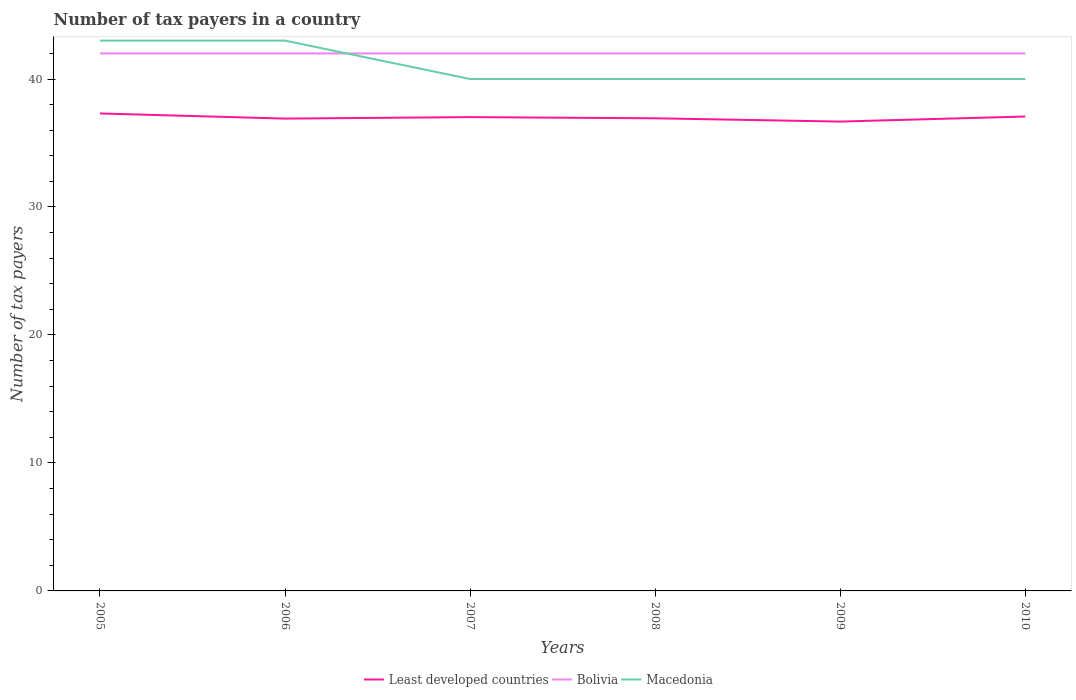How many different coloured lines are there?
Your answer should be very brief. 3. Is the number of lines equal to the number of legend labels?
Give a very brief answer. Yes. Across all years, what is the maximum number of tax payers in in Bolivia?
Your answer should be very brief. 42. What is the total number of tax payers in in Bolivia in the graph?
Your answer should be very brief. 0. What is the difference between the highest and the second highest number of tax payers in in Macedonia?
Give a very brief answer. 3. What is the difference between the highest and the lowest number of tax payers in in Macedonia?
Ensure brevity in your answer.  2. What is the difference between two consecutive major ticks on the Y-axis?
Give a very brief answer. 10. Are the values on the major ticks of Y-axis written in scientific E-notation?
Keep it short and to the point. No. Does the graph contain grids?
Your answer should be very brief. No. How many legend labels are there?
Your response must be concise. 3. How are the legend labels stacked?
Ensure brevity in your answer.  Horizontal. What is the title of the graph?
Keep it short and to the point. Number of tax payers in a country. Does "French Polynesia" appear as one of the legend labels in the graph?
Your answer should be compact. No. What is the label or title of the X-axis?
Ensure brevity in your answer.  Years. What is the label or title of the Y-axis?
Give a very brief answer. Number of tax payers. What is the Number of tax payers in Least developed countries in 2005?
Your answer should be very brief. 37.31. What is the Number of tax payers of Least developed countries in 2006?
Provide a succinct answer. 36.91. What is the Number of tax payers in Macedonia in 2006?
Offer a terse response. 43. What is the Number of tax payers in Least developed countries in 2007?
Ensure brevity in your answer.  37.02. What is the Number of tax payers of Bolivia in 2007?
Ensure brevity in your answer.  42. What is the Number of tax payers in Macedonia in 2007?
Keep it short and to the point. 40. What is the Number of tax payers in Least developed countries in 2008?
Provide a succinct answer. 36.93. What is the Number of tax payers in Least developed countries in 2009?
Provide a succinct answer. 36.67. What is the Number of tax payers in Bolivia in 2009?
Provide a short and direct response. 42. What is the Number of tax payers in Macedonia in 2009?
Give a very brief answer. 40. What is the Number of tax payers of Least developed countries in 2010?
Keep it short and to the point. 37.07. What is the Number of tax payers of Bolivia in 2010?
Keep it short and to the point. 42. Across all years, what is the maximum Number of tax payers in Least developed countries?
Your answer should be very brief. 37.31. Across all years, what is the minimum Number of tax payers in Least developed countries?
Offer a very short reply. 36.67. Across all years, what is the minimum Number of tax payers in Macedonia?
Your answer should be compact. 40. What is the total Number of tax payers of Least developed countries in the graph?
Provide a short and direct response. 221.91. What is the total Number of tax payers of Bolivia in the graph?
Make the answer very short. 252. What is the total Number of tax payers of Macedonia in the graph?
Your response must be concise. 246. What is the difference between the Number of tax payers of Least developed countries in 2005 and that in 2006?
Provide a succinct answer. 0.4. What is the difference between the Number of tax payers of Bolivia in 2005 and that in 2006?
Offer a very short reply. 0. What is the difference between the Number of tax payers of Macedonia in 2005 and that in 2006?
Give a very brief answer. 0. What is the difference between the Number of tax payers in Least developed countries in 2005 and that in 2007?
Ensure brevity in your answer.  0.29. What is the difference between the Number of tax payers of Bolivia in 2005 and that in 2007?
Your answer should be compact. 0. What is the difference between the Number of tax payers of Least developed countries in 2005 and that in 2008?
Provide a short and direct response. 0.38. What is the difference between the Number of tax payers in Least developed countries in 2005 and that in 2009?
Keep it short and to the point. 0.64. What is the difference between the Number of tax payers of Least developed countries in 2005 and that in 2010?
Your response must be concise. 0.24. What is the difference between the Number of tax payers in Macedonia in 2005 and that in 2010?
Provide a succinct answer. 3. What is the difference between the Number of tax payers of Least developed countries in 2006 and that in 2007?
Offer a very short reply. -0.12. What is the difference between the Number of tax payers in Bolivia in 2006 and that in 2007?
Offer a terse response. 0. What is the difference between the Number of tax payers of Least developed countries in 2006 and that in 2008?
Keep it short and to the point. -0.02. What is the difference between the Number of tax payers of Macedonia in 2006 and that in 2008?
Make the answer very short. 3. What is the difference between the Number of tax payers of Least developed countries in 2006 and that in 2009?
Ensure brevity in your answer.  0.23. What is the difference between the Number of tax payers in Bolivia in 2006 and that in 2009?
Provide a short and direct response. 0. What is the difference between the Number of tax payers in Macedonia in 2006 and that in 2009?
Provide a succinct answer. 3. What is the difference between the Number of tax payers of Least developed countries in 2006 and that in 2010?
Keep it short and to the point. -0.16. What is the difference between the Number of tax payers in Least developed countries in 2007 and that in 2008?
Your answer should be very brief. 0.09. What is the difference between the Number of tax payers in Least developed countries in 2007 and that in 2009?
Your answer should be very brief. 0.35. What is the difference between the Number of tax payers in Bolivia in 2007 and that in 2009?
Keep it short and to the point. 0. What is the difference between the Number of tax payers of Macedonia in 2007 and that in 2009?
Your answer should be very brief. 0. What is the difference between the Number of tax payers in Least developed countries in 2007 and that in 2010?
Offer a very short reply. -0.05. What is the difference between the Number of tax payers of Bolivia in 2007 and that in 2010?
Give a very brief answer. 0. What is the difference between the Number of tax payers of Least developed countries in 2008 and that in 2009?
Keep it short and to the point. 0.26. What is the difference between the Number of tax payers of Macedonia in 2008 and that in 2009?
Offer a terse response. 0. What is the difference between the Number of tax payers in Least developed countries in 2008 and that in 2010?
Provide a succinct answer. -0.14. What is the difference between the Number of tax payers in Bolivia in 2008 and that in 2010?
Make the answer very short. 0. What is the difference between the Number of tax payers in Macedonia in 2008 and that in 2010?
Provide a succinct answer. 0. What is the difference between the Number of tax payers of Least developed countries in 2009 and that in 2010?
Offer a very short reply. -0.4. What is the difference between the Number of tax payers of Bolivia in 2009 and that in 2010?
Offer a very short reply. 0. What is the difference between the Number of tax payers in Least developed countries in 2005 and the Number of tax payers in Bolivia in 2006?
Your answer should be very brief. -4.69. What is the difference between the Number of tax payers in Least developed countries in 2005 and the Number of tax payers in Macedonia in 2006?
Provide a short and direct response. -5.69. What is the difference between the Number of tax payers of Bolivia in 2005 and the Number of tax payers of Macedonia in 2006?
Keep it short and to the point. -1. What is the difference between the Number of tax payers of Least developed countries in 2005 and the Number of tax payers of Bolivia in 2007?
Provide a succinct answer. -4.69. What is the difference between the Number of tax payers in Least developed countries in 2005 and the Number of tax payers in Macedonia in 2007?
Provide a succinct answer. -2.69. What is the difference between the Number of tax payers of Bolivia in 2005 and the Number of tax payers of Macedonia in 2007?
Provide a succinct answer. 2. What is the difference between the Number of tax payers of Least developed countries in 2005 and the Number of tax payers of Bolivia in 2008?
Ensure brevity in your answer.  -4.69. What is the difference between the Number of tax payers in Least developed countries in 2005 and the Number of tax payers in Macedonia in 2008?
Give a very brief answer. -2.69. What is the difference between the Number of tax payers of Least developed countries in 2005 and the Number of tax payers of Bolivia in 2009?
Keep it short and to the point. -4.69. What is the difference between the Number of tax payers of Least developed countries in 2005 and the Number of tax payers of Macedonia in 2009?
Offer a very short reply. -2.69. What is the difference between the Number of tax payers of Least developed countries in 2005 and the Number of tax payers of Bolivia in 2010?
Keep it short and to the point. -4.69. What is the difference between the Number of tax payers in Least developed countries in 2005 and the Number of tax payers in Macedonia in 2010?
Provide a succinct answer. -2.69. What is the difference between the Number of tax payers in Bolivia in 2005 and the Number of tax payers in Macedonia in 2010?
Make the answer very short. 2. What is the difference between the Number of tax payers of Least developed countries in 2006 and the Number of tax payers of Bolivia in 2007?
Your answer should be very brief. -5.09. What is the difference between the Number of tax payers of Least developed countries in 2006 and the Number of tax payers of Macedonia in 2007?
Your answer should be very brief. -3.09. What is the difference between the Number of tax payers of Least developed countries in 2006 and the Number of tax payers of Bolivia in 2008?
Offer a terse response. -5.09. What is the difference between the Number of tax payers in Least developed countries in 2006 and the Number of tax payers in Macedonia in 2008?
Your answer should be compact. -3.09. What is the difference between the Number of tax payers in Least developed countries in 2006 and the Number of tax payers in Bolivia in 2009?
Your response must be concise. -5.09. What is the difference between the Number of tax payers in Least developed countries in 2006 and the Number of tax payers in Macedonia in 2009?
Provide a succinct answer. -3.09. What is the difference between the Number of tax payers in Least developed countries in 2006 and the Number of tax payers in Bolivia in 2010?
Make the answer very short. -5.09. What is the difference between the Number of tax payers of Least developed countries in 2006 and the Number of tax payers of Macedonia in 2010?
Ensure brevity in your answer.  -3.09. What is the difference between the Number of tax payers in Least developed countries in 2007 and the Number of tax payers in Bolivia in 2008?
Your answer should be very brief. -4.98. What is the difference between the Number of tax payers in Least developed countries in 2007 and the Number of tax payers in Macedonia in 2008?
Keep it short and to the point. -2.98. What is the difference between the Number of tax payers of Least developed countries in 2007 and the Number of tax payers of Bolivia in 2009?
Provide a short and direct response. -4.98. What is the difference between the Number of tax payers in Least developed countries in 2007 and the Number of tax payers in Macedonia in 2009?
Provide a short and direct response. -2.98. What is the difference between the Number of tax payers in Least developed countries in 2007 and the Number of tax payers in Bolivia in 2010?
Keep it short and to the point. -4.98. What is the difference between the Number of tax payers of Least developed countries in 2007 and the Number of tax payers of Macedonia in 2010?
Your answer should be very brief. -2.98. What is the difference between the Number of tax payers of Least developed countries in 2008 and the Number of tax payers of Bolivia in 2009?
Your response must be concise. -5.07. What is the difference between the Number of tax payers in Least developed countries in 2008 and the Number of tax payers in Macedonia in 2009?
Ensure brevity in your answer.  -3.07. What is the difference between the Number of tax payers of Bolivia in 2008 and the Number of tax payers of Macedonia in 2009?
Your answer should be very brief. 2. What is the difference between the Number of tax payers in Least developed countries in 2008 and the Number of tax payers in Bolivia in 2010?
Give a very brief answer. -5.07. What is the difference between the Number of tax payers in Least developed countries in 2008 and the Number of tax payers in Macedonia in 2010?
Make the answer very short. -3.07. What is the difference between the Number of tax payers in Bolivia in 2008 and the Number of tax payers in Macedonia in 2010?
Your response must be concise. 2. What is the difference between the Number of tax payers in Least developed countries in 2009 and the Number of tax payers in Bolivia in 2010?
Provide a short and direct response. -5.33. What is the difference between the Number of tax payers of Least developed countries in 2009 and the Number of tax payers of Macedonia in 2010?
Make the answer very short. -3.33. What is the average Number of tax payers of Least developed countries per year?
Ensure brevity in your answer.  36.99. What is the average Number of tax payers in Macedonia per year?
Make the answer very short. 41. In the year 2005, what is the difference between the Number of tax payers in Least developed countries and Number of tax payers in Bolivia?
Make the answer very short. -4.69. In the year 2005, what is the difference between the Number of tax payers of Least developed countries and Number of tax payers of Macedonia?
Your response must be concise. -5.69. In the year 2005, what is the difference between the Number of tax payers in Bolivia and Number of tax payers in Macedonia?
Give a very brief answer. -1. In the year 2006, what is the difference between the Number of tax payers of Least developed countries and Number of tax payers of Bolivia?
Give a very brief answer. -5.09. In the year 2006, what is the difference between the Number of tax payers of Least developed countries and Number of tax payers of Macedonia?
Your answer should be very brief. -6.09. In the year 2006, what is the difference between the Number of tax payers in Bolivia and Number of tax payers in Macedonia?
Your response must be concise. -1. In the year 2007, what is the difference between the Number of tax payers of Least developed countries and Number of tax payers of Bolivia?
Give a very brief answer. -4.98. In the year 2007, what is the difference between the Number of tax payers in Least developed countries and Number of tax payers in Macedonia?
Your answer should be very brief. -2.98. In the year 2008, what is the difference between the Number of tax payers of Least developed countries and Number of tax payers of Bolivia?
Provide a short and direct response. -5.07. In the year 2008, what is the difference between the Number of tax payers of Least developed countries and Number of tax payers of Macedonia?
Give a very brief answer. -3.07. In the year 2009, what is the difference between the Number of tax payers in Least developed countries and Number of tax payers in Bolivia?
Ensure brevity in your answer.  -5.33. In the year 2009, what is the difference between the Number of tax payers of Least developed countries and Number of tax payers of Macedonia?
Offer a very short reply. -3.33. In the year 2009, what is the difference between the Number of tax payers in Bolivia and Number of tax payers in Macedonia?
Give a very brief answer. 2. In the year 2010, what is the difference between the Number of tax payers of Least developed countries and Number of tax payers of Bolivia?
Offer a very short reply. -4.93. In the year 2010, what is the difference between the Number of tax payers in Least developed countries and Number of tax payers in Macedonia?
Offer a terse response. -2.93. In the year 2010, what is the difference between the Number of tax payers of Bolivia and Number of tax payers of Macedonia?
Provide a short and direct response. 2. What is the ratio of the Number of tax payers in Least developed countries in 2005 to that in 2006?
Provide a succinct answer. 1.01. What is the ratio of the Number of tax payers of Least developed countries in 2005 to that in 2007?
Provide a succinct answer. 1.01. What is the ratio of the Number of tax payers in Macedonia in 2005 to that in 2007?
Offer a very short reply. 1.07. What is the ratio of the Number of tax payers in Least developed countries in 2005 to that in 2008?
Your response must be concise. 1.01. What is the ratio of the Number of tax payers of Bolivia in 2005 to that in 2008?
Your answer should be very brief. 1. What is the ratio of the Number of tax payers in Macedonia in 2005 to that in 2008?
Keep it short and to the point. 1.07. What is the ratio of the Number of tax payers of Least developed countries in 2005 to that in 2009?
Give a very brief answer. 1.02. What is the ratio of the Number of tax payers of Bolivia in 2005 to that in 2009?
Your response must be concise. 1. What is the ratio of the Number of tax payers in Macedonia in 2005 to that in 2009?
Make the answer very short. 1.07. What is the ratio of the Number of tax payers of Least developed countries in 2005 to that in 2010?
Make the answer very short. 1.01. What is the ratio of the Number of tax payers of Bolivia in 2005 to that in 2010?
Provide a succinct answer. 1. What is the ratio of the Number of tax payers of Macedonia in 2005 to that in 2010?
Keep it short and to the point. 1.07. What is the ratio of the Number of tax payers of Least developed countries in 2006 to that in 2007?
Offer a very short reply. 1. What is the ratio of the Number of tax payers in Macedonia in 2006 to that in 2007?
Keep it short and to the point. 1.07. What is the ratio of the Number of tax payers in Macedonia in 2006 to that in 2008?
Make the answer very short. 1.07. What is the ratio of the Number of tax payers in Bolivia in 2006 to that in 2009?
Make the answer very short. 1. What is the ratio of the Number of tax payers in Macedonia in 2006 to that in 2009?
Offer a terse response. 1.07. What is the ratio of the Number of tax payers in Bolivia in 2006 to that in 2010?
Offer a terse response. 1. What is the ratio of the Number of tax payers in Macedonia in 2006 to that in 2010?
Your answer should be very brief. 1.07. What is the ratio of the Number of tax payers of Least developed countries in 2007 to that in 2009?
Your answer should be very brief. 1.01. What is the ratio of the Number of tax payers of Bolivia in 2007 to that in 2009?
Keep it short and to the point. 1. What is the ratio of the Number of tax payers of Least developed countries in 2007 to that in 2010?
Your answer should be compact. 1. What is the ratio of the Number of tax payers of Macedonia in 2007 to that in 2010?
Your answer should be compact. 1. What is the ratio of the Number of tax payers in Bolivia in 2008 to that in 2009?
Offer a terse response. 1. What is the ratio of the Number of tax payers in Bolivia in 2008 to that in 2010?
Your answer should be compact. 1. What is the ratio of the Number of tax payers of Macedonia in 2008 to that in 2010?
Provide a succinct answer. 1. What is the ratio of the Number of tax payers in Least developed countries in 2009 to that in 2010?
Ensure brevity in your answer.  0.99. What is the ratio of the Number of tax payers of Macedonia in 2009 to that in 2010?
Provide a succinct answer. 1. What is the difference between the highest and the second highest Number of tax payers in Least developed countries?
Provide a short and direct response. 0.24. What is the difference between the highest and the second highest Number of tax payers in Bolivia?
Your answer should be compact. 0. What is the difference between the highest and the second highest Number of tax payers in Macedonia?
Keep it short and to the point. 0. What is the difference between the highest and the lowest Number of tax payers of Least developed countries?
Make the answer very short. 0.64. 